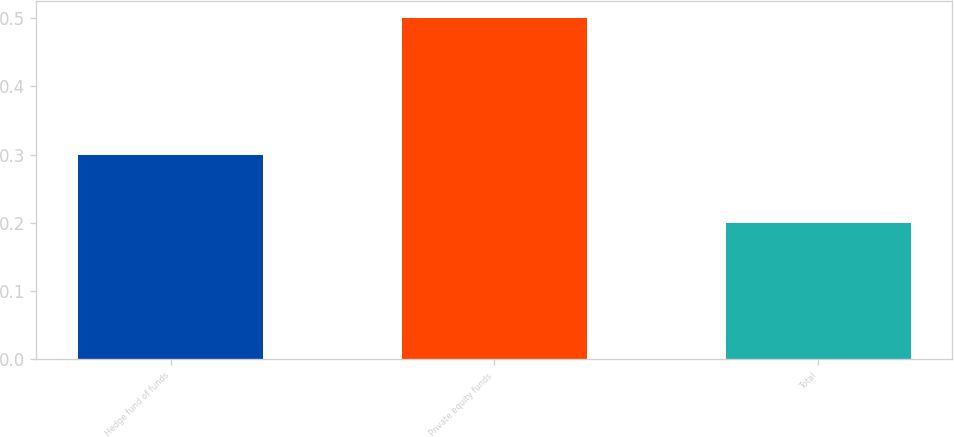Convert chart. <chart><loc_0><loc_0><loc_500><loc_500><bar_chart><fcel>Hedge fund of funds<fcel>Private equity funds<fcel>Total<nl><fcel>0.3<fcel>0.5<fcel>0.2<nl></chart> 